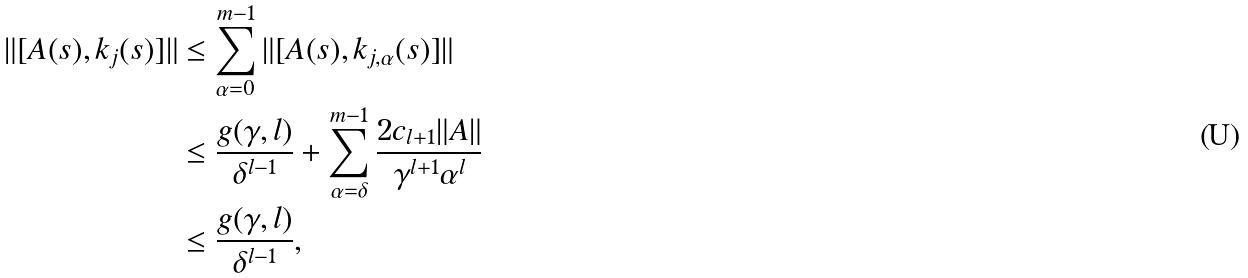<formula> <loc_0><loc_0><loc_500><loc_500>\| [ A ( s ) , k _ { j } ( s ) ] \| & \leq \sum _ { \alpha = 0 } ^ { m - 1 } \| [ A ( s ) , k _ { j , \alpha } ( s ) ] \| \\ & \leq \frac { g ( \gamma , l ) } { \delta ^ { l - 1 } } + \sum _ { \alpha = \delta } ^ { m - 1 } \frac { 2 c _ { l + 1 } \| A \| } { \gamma ^ { l + 1 } \alpha ^ { l } } \\ & \leq \frac { g ( \gamma , l ) } { \delta ^ { l - 1 } } ,</formula> 